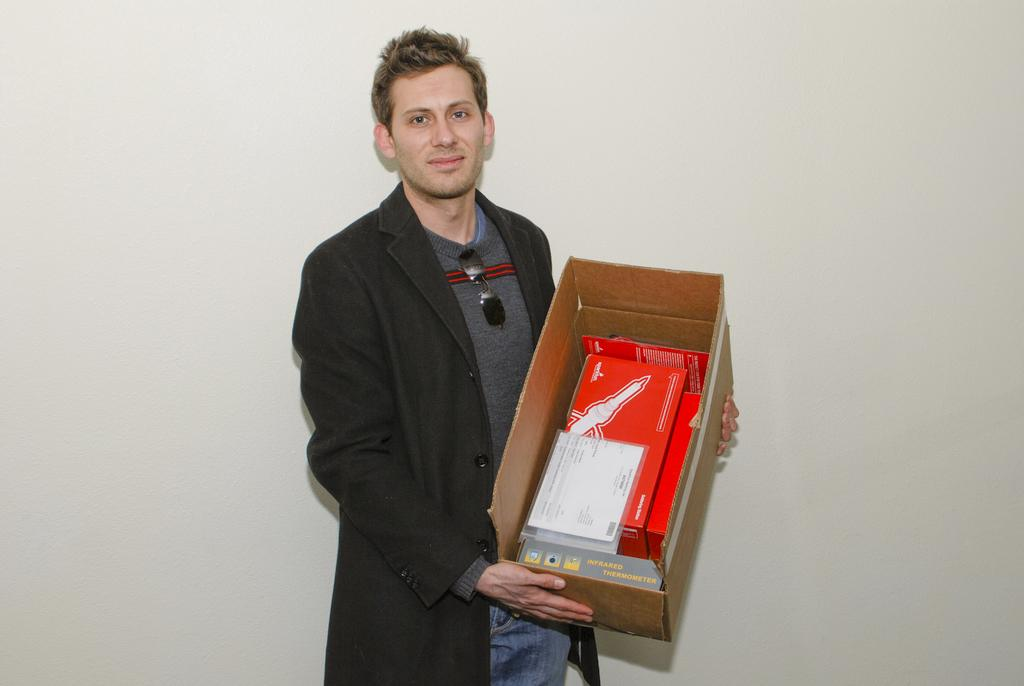Who is the main subject in the image? There is a man in the image. Where is the man positioned in the image? The man is standing in the middle of the image. What is the man holding in the image? The man is holding a box. What is the man's facial expression in the image? The man is smiling. What can be seen behind the man in the image? There is a wall behind the man. What type of knife is the man using to perform addition in the image? There is no knife or addition being performed in the image; the man is simply holding a box and smiling. 